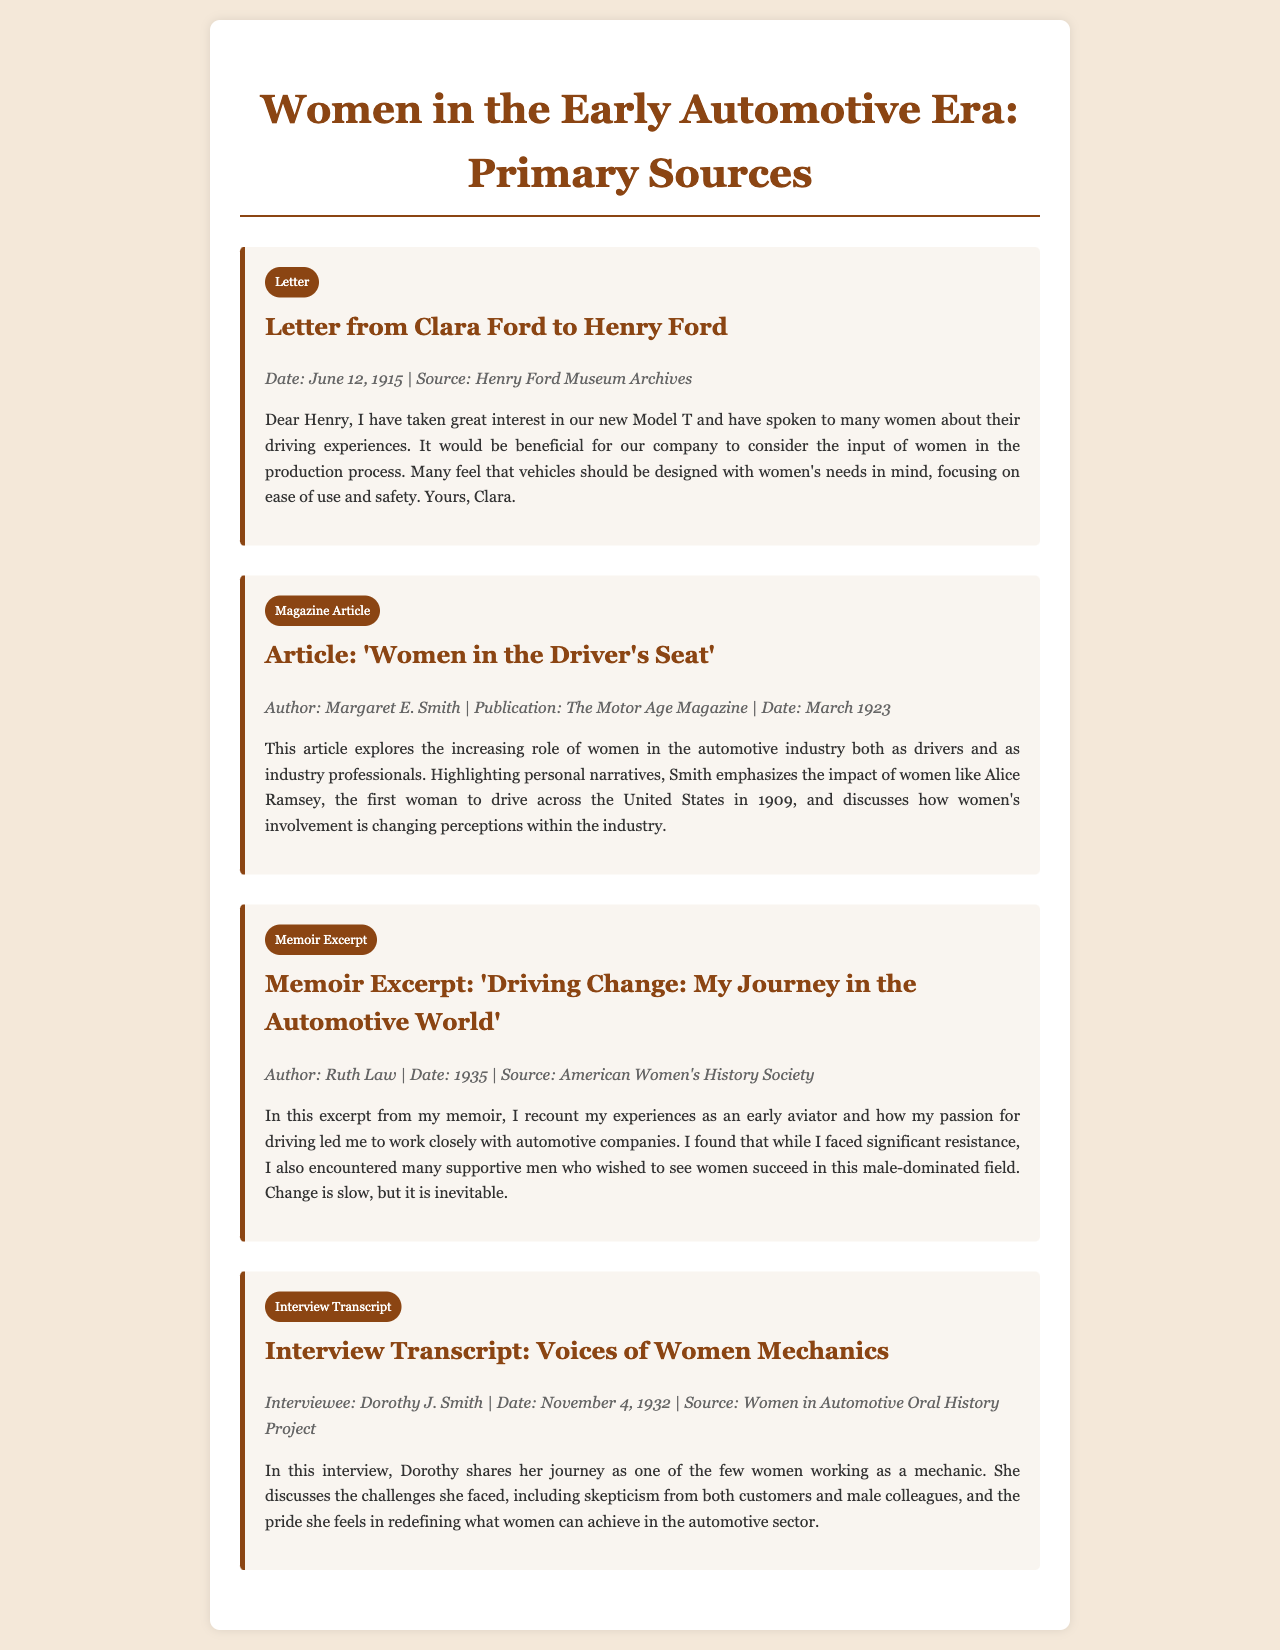what is the date of Clara Ford's letter to Henry Ford? The date mentioned in the letter is June 12, 1915.
Answer: June 12, 1915 who wrote the article 'Women in the Driver's Seat'? The article is authored by Margaret E. Smith.
Answer: Margaret E. Smith what year was Ruth Law's memoir excerpt published? The memoir excerpt was published in 1935.
Answer: 1935 what is the main topic of the article by Margaret E. Smith? The article discusses women's increasing role in the automotive industry both as drivers and as industry professionals.
Answer: Women's increasing role in the automotive industry what is the source of the interview transcript with Dorothy J. Smith? The interview is sourced from the Women in Automotive Oral History Project.
Answer: Women in Automotive Oral History Project how does Dorothy J. Smith feel about being a mechanic? She expresses pride in redefining what women can achieve in the automotive sector.
Answer: Pride in what year did Alice Ramsey drive across the United States? Alice Ramsey completed her drive in 1909.
Answer: 1909 what type of document is the excerpt from Ruth Law's memoir? The excerpt is classified as a memoir excerpt.
Answer: Memoir Excerpt how does Clara Ford suggest that vehicles should be designed? Clara suggests that vehicles should be designed with women's needs in mind, focusing on ease of use and safety.
Answer: With women's needs in mind, focusing on ease of use and safety 